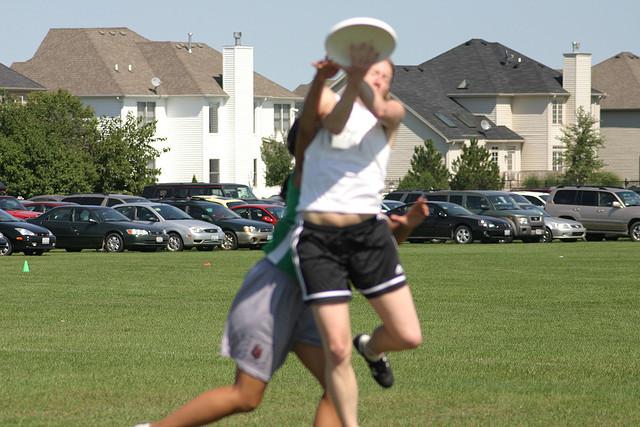Are they fighting over the frisbee?
Short answer required. Yes. How many vehicles are in the background?
Give a very brief answer. 20. Are there many cars in the background?
Keep it brief. Yes. Are these women experienced in frisbee?
Be succinct. Yes. Is she about to fall?
Concise answer only. No. 